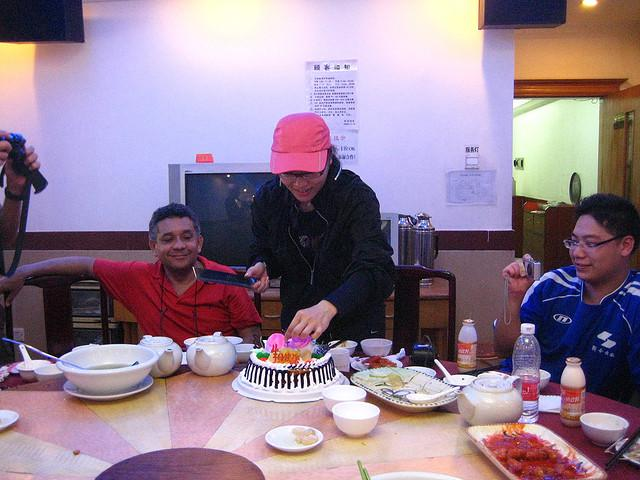What is the woman doing with the knife? cutting 